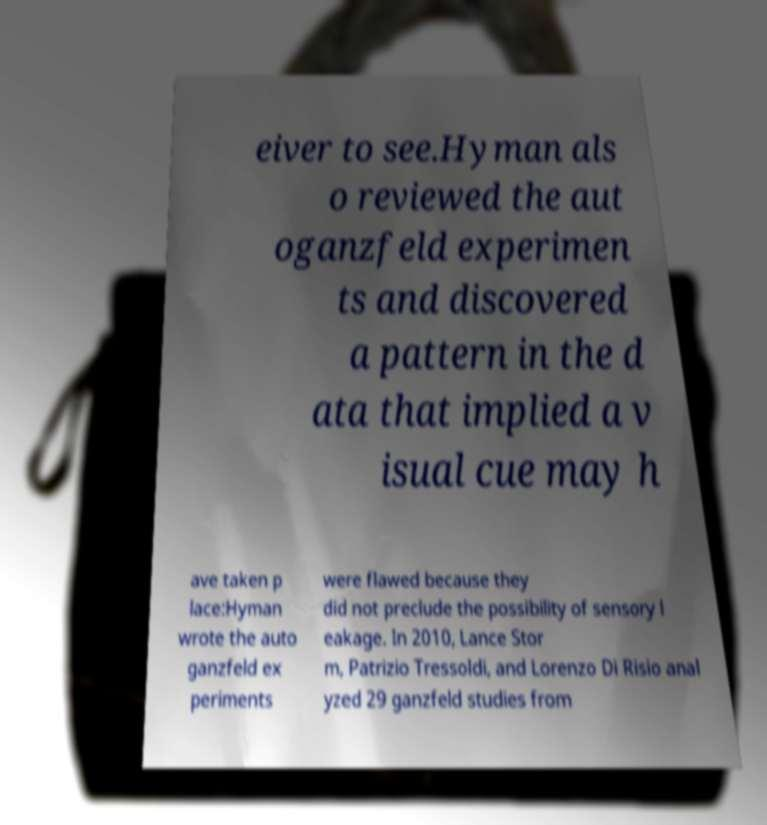Could you assist in decoding the text presented in this image and type it out clearly? eiver to see.Hyman als o reviewed the aut oganzfeld experimen ts and discovered a pattern in the d ata that implied a v isual cue may h ave taken p lace:Hyman wrote the auto ganzfeld ex periments were flawed because they did not preclude the possibility of sensory l eakage. In 2010, Lance Stor m, Patrizio Tressoldi, and Lorenzo Di Risio anal yzed 29 ganzfeld studies from 